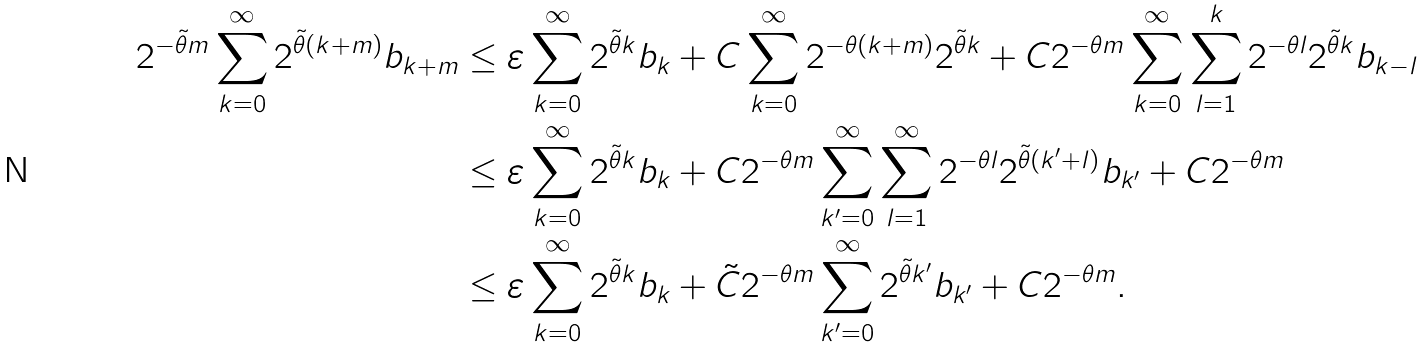<formula> <loc_0><loc_0><loc_500><loc_500>2 ^ { - \tilde { \theta } m } \sum _ { k = 0 } ^ { \infty } { 2 } ^ { \tilde { \theta } ( k + m ) } b _ { k + m } & \leq \varepsilon \sum _ { k = 0 } ^ { \infty } 2 ^ { \tilde { \theta } k } b _ { k } + C \sum _ { k = 0 } ^ { \infty } 2 ^ { - \theta ( k + m ) } 2 ^ { \tilde { \theta } k } + C 2 ^ { - \theta m } \sum _ { k = 0 } ^ { \infty } \sum _ { l = 1 } ^ { k } 2 ^ { - \theta l } 2 ^ { \tilde { \theta } k } b _ { k - l } \\ & \leq \varepsilon \sum _ { k = 0 } ^ { \infty } 2 ^ { \tilde { \theta } k } b _ { k } + C 2 ^ { - \theta m } \sum _ { k ^ { \prime } = 0 } ^ { \infty } \sum _ { l = 1 } ^ { \infty } 2 ^ { - \theta l } 2 ^ { \tilde { \theta } ( k ^ { \prime } + l ) } b _ { k ^ { \prime } } + C 2 ^ { - \theta m } \\ & \leq \varepsilon \sum _ { k = 0 } ^ { \infty } 2 ^ { \tilde { \theta } k } b _ { k } + \tilde { C } 2 ^ { - \theta m } \sum _ { k ^ { \prime } = 0 } ^ { \infty } 2 ^ { \tilde { \theta } k ^ { \prime } } b _ { k ^ { \prime } } + C 2 ^ { - \theta m } .</formula> 